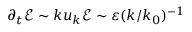<formula> <loc_0><loc_0><loc_500><loc_500>\partial _ { t } \mathcal { E } \sim k u _ { k } \mathcal { E } \sim \varepsilon ( k / k _ { 0 } ) ^ { - 1 }</formula> 